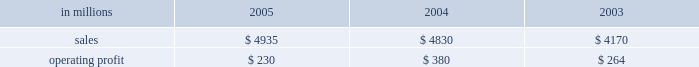Entering 2006 , earnings in the first quarter are ex- pected to improve compared with the 2005 fourth quar- ter due principally to higher average price realizations , reflecting announced price increases .
Product demand for the first quarter should be seasonally slow , but is ex- pected to strengthen as the year progresses , supported by continued economic growth in north america , asia and eastern europe .
Average prices should also improve in 2006 as price increases announced in late 2005 and early 2006 for uncoated freesheet paper and pulp con- tinue to be realized .
Operating rates are expected to improve as a result of industry-wide capacity reductions in 2005 .
Although energy and raw material costs remain high , there has been some decline in both natural gas and delivered wood costs , with further moderation ex- pected later in 2006 .
We will continue to focus on fur- ther improvements in our global manufacturing operations , implementation of supply chain enhance- ments and reductions in overhead costs during 2006 .
Industrial packaging demand for industrial packaging products is closely correlated with non-durable industrial goods production in the united states , as well as with demand for proc- essed foods , poultry , meat and agricultural products .
In addition to prices and volumes , major factors affecting the profitability of industrial packaging are raw material and energy costs , manufacturing efficiency and product industrial packaging 2019s net sales for 2005 increased 2% ( 2 % ) compared with 2004 , and were 18% ( 18 % ) higher than in 2003 , reflecting the inclusion of international paper distribution limited ( formerly international paper pacific millennium limited ) beginning in august 2005 .
Operating profits in 2005 were 39% ( 39 % ) lower than in 2004 and 13% ( 13 % ) lower than in 2003 .
Sales volume increases ( $ 24 million ) , improved price realizations ( $ 66 million ) , and strong mill operating performance ( $ 27 million ) were not enough to offset the effects of increased raw material costs ( $ 103 million ) , higher market related downtime costs ( $ 50 million ) , higher converting operating costs ( $ 22 million ) , and unfavorable mix and other costs ( $ 67 million ) .
Additionally , the may 2005 sale of our industrial papers business resulted in a $ 25 million lower earnings contribution from this business in 2005 .
The segment took 370000 tons of downtime in 2005 , including 230000 tons of lack-of-order downtime to balance internal supply with customer demand , com- pared to a total of 170000 tons in 2004 , which included 5000 tons of lack-of-order downtime .
Industrial packaging in millions 2005 2004 2003 .
Containerboard 2019s net sales totaled $ 895 million in 2005 , $ 951 million in 2004 and $ 815 million in 2003 .
Soft market conditions and declining customer demand at the end of the first quarter led to lower average sales prices during the second and third quarters .
Beginning in the fourth quarter , prices recovered as a result of in- creased customer demand and a rationalization of sup- ply .
Full year sales volumes trailed 2004 levels early in the year , reflecting the weak market conditions in the first half of 2005 .
However , volumes rebounded in the second half of the year , and finished the year ahead of 2004 levels .
Operating profits decreased 38% ( 38 % ) from 2004 , but were flat with 2003 .
The favorable impacts of in- creased sales volumes , higher average sales prices and improved mill operating performance were not enough to offset the impact of higher wood , energy and other raw material costs and increased lack-of-order down- time .
Implementation of the new supply chain operating model in our containerboard mills during 2005 resulted in increased operating efficiency and cost savings .
Specialty papers in 2005 included the kraft paper business for the full year and the industrial papers busi- ness for five months prior to its sale in may 2005 .
Net sales totaled $ 468 million in 2005 , $ 723 million in 2004 and $ 690 million in 2003 .
Operating profits in 2005 were down 23% ( 23 % ) compared with 2004 and 54% ( 54 % ) com- pared with 2003 , reflecting the lower contribution from industrial papers .
U.s .
Converting operations net sales for 2005 were $ 2.6 billion compared with $ 2.3 billion in 2004 and $ 1.9 billion in 2003 .
Sales volumes were up 10% ( 10 % ) in 2005 compared with 2004 , mainly due to the acquisition of box usa in july 2004 .
Average sales prices in 2005 began the year above 2004 levels , but softened in the second half of the year .
Operating profits in 2005 de- creased 46% ( 46 % ) and 4% ( 4 % ) from 2004 and 2003 levels , re- spectively , primarily due to increased linerboard , freight and energy costs .
European container sales for 2005 were $ 883 mil- lion compared with $ 865 million in 2004 and $ 801 mil- lion in 2003 .
Operating profits declined 19% ( 19 % ) and 13% ( 13 % ) compared with 2004 and 2003 , respectively .
The in- crease in sales in 2005 reflected a slight increase in de- mand over 2004 , but this was not sufficient to offset the negative earnings effect of increased operating costs , unfavorable foreign exchange rates and a reduction in average sales prices .
The moroccan box plant acquis- ition , which was completed in october 2005 , favorably impacted fourth-quarter results .
Industrial packaging 2019s sales in 2005 included $ 104 million from international paper distribution limited , our asian box and containerboard business , subsequent to the acquisition of an additional 50% ( 50 % ) interest in au- gust 2005. .
What was the industrial packaging profit margin in 2003? 
Computations: (264 / 4170)
Answer: 0.06331. 